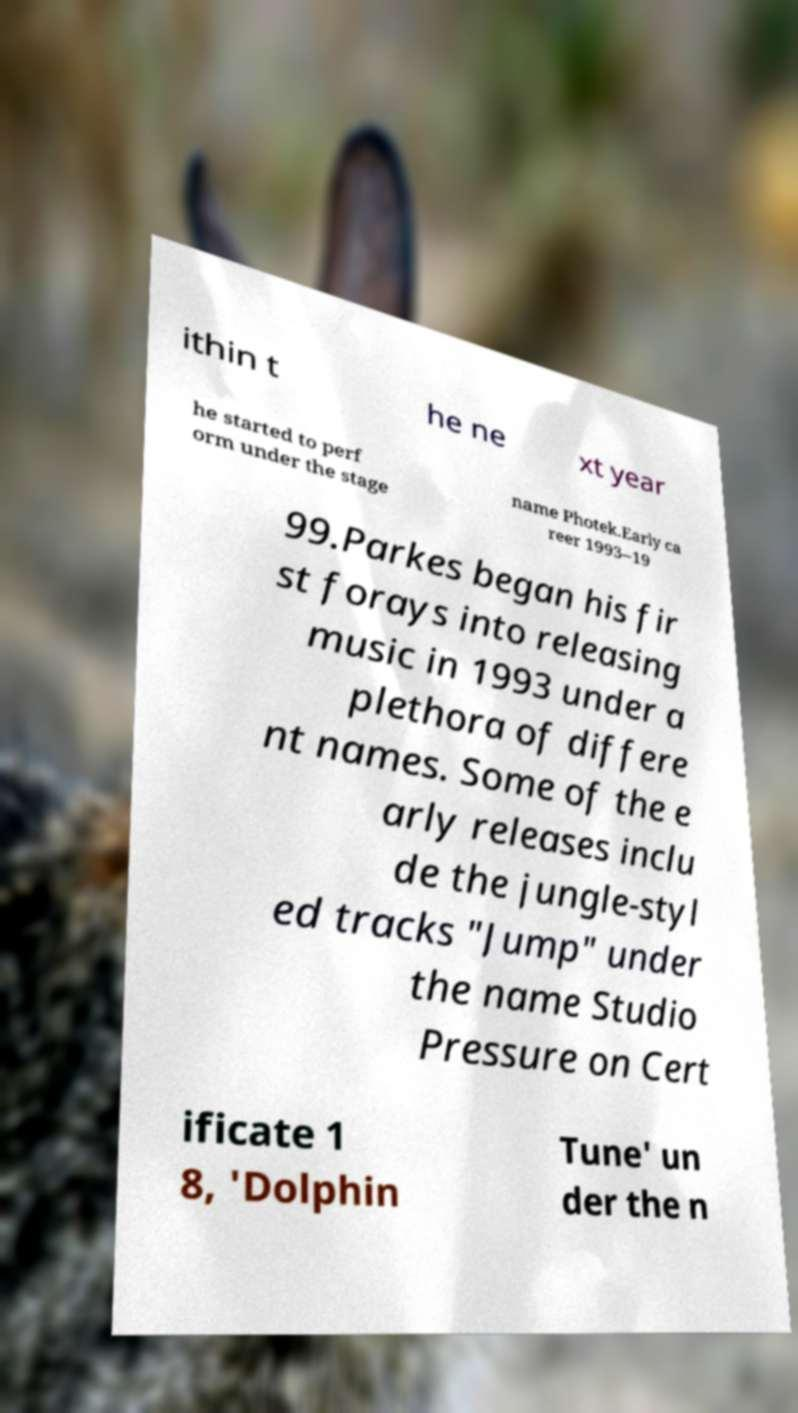Could you extract and type out the text from this image? ithin t he ne xt year he started to perf orm under the stage name Photek.Early ca reer 1993–19 99.Parkes began his fir st forays into releasing music in 1993 under a plethora of differe nt names. Some of the e arly releases inclu de the jungle-styl ed tracks "Jump" under the name Studio Pressure on Cert ificate 1 8, 'Dolphin Tune' un der the n 